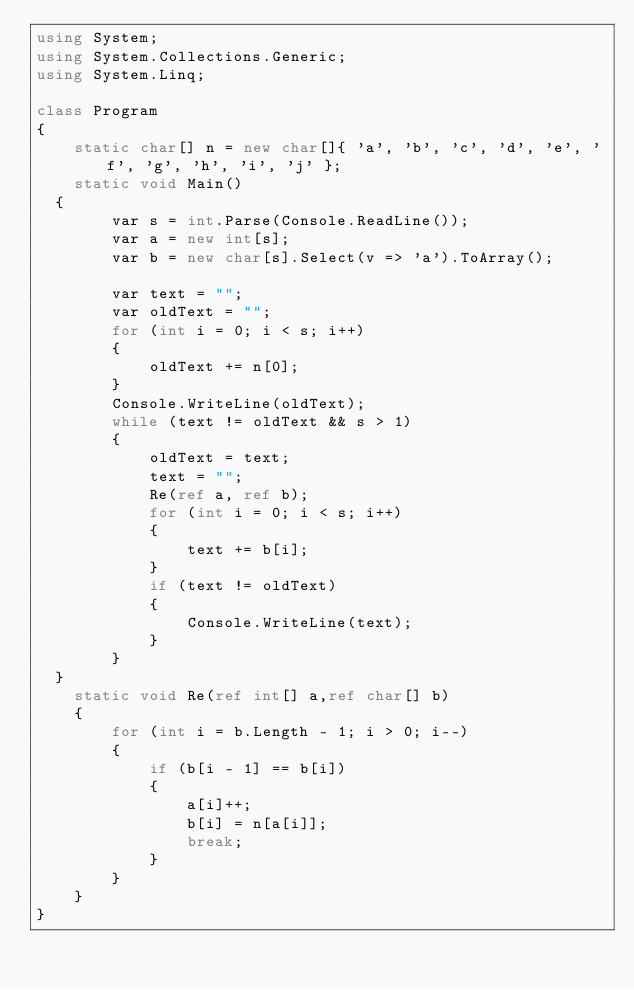<code> <loc_0><loc_0><loc_500><loc_500><_C#_>using System;
using System.Collections.Generic;
using System.Linq;

class Program
{
    static char[] n = new char[]{ 'a', 'b', 'c', 'd', 'e', 'f', 'g', 'h', 'i', 'j' };
    static void Main()
	{
        var s = int.Parse(Console.ReadLine());
        var a = new int[s];
        var b = new char[s].Select(v => 'a').ToArray();

        var text = "";
        var oldText = "";
        for (int i = 0; i < s; i++)
        {
            oldText += n[0];
        }
        Console.WriteLine(oldText);
        while (text != oldText && s > 1)
        {
            oldText = text;
            text = "";
            Re(ref a, ref b);
            for (int i = 0; i < s; i++)
            {
                text += b[i];
            }
            if (text != oldText)
            {
                Console.WriteLine(text);
            }
        }
	}
    static void Re(ref int[] a,ref char[] b)
    {
        for (int i = b.Length - 1; i > 0; i--)
        {
            if (b[i - 1] == b[i])
            {
                a[i]++;
                b[i] = n[a[i]];
                break;
            }
        }
    }
}</code> 